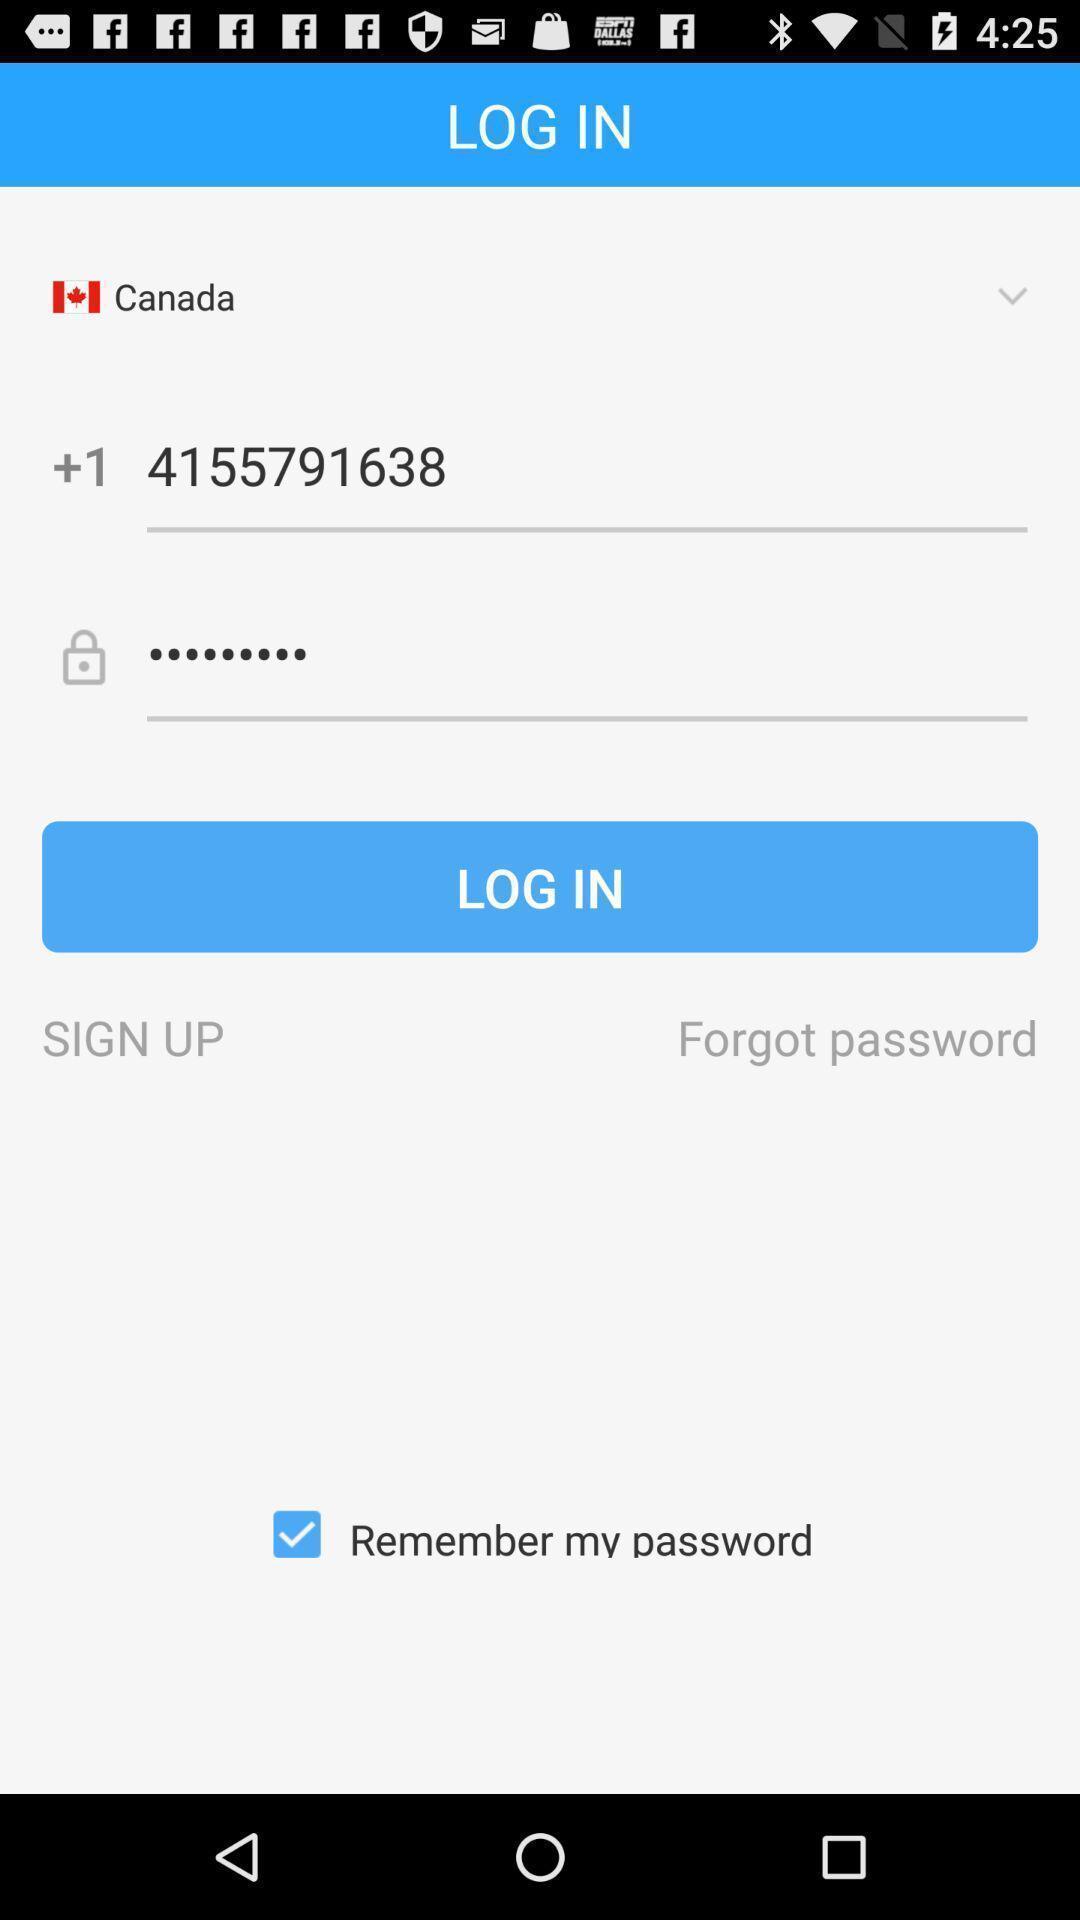What details can you identify in this image? Login page. 